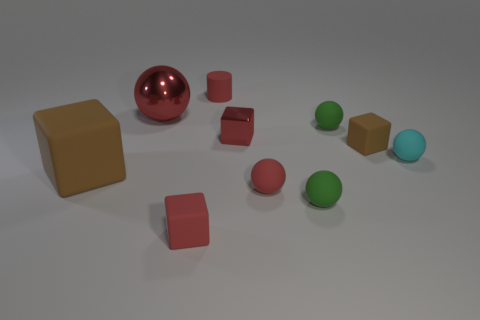There is a rubber cylinder that is the same size as the metallic cube; what is its color?
Give a very brief answer. Red. Is the number of small objects that are to the right of the cyan thing less than the number of cylinders left of the big block?
Your answer should be compact. No. What number of tiny spheres are to the left of the red metal thing to the right of the small red cube that is in front of the small brown block?
Provide a succinct answer. 0. There is another shiny object that is the same shape as the cyan thing; what size is it?
Offer a very short reply. Large. Is there anything else that is the same size as the red cylinder?
Your answer should be compact. Yes. Is the number of metallic balls to the right of the big red thing less than the number of tiny red metallic cubes?
Keep it short and to the point. Yes. Is the big red object the same shape as the small brown thing?
Ensure brevity in your answer.  No. What color is the other metallic object that is the same shape as the big brown thing?
Ensure brevity in your answer.  Red. What number of rubber objects are the same color as the metallic block?
Keep it short and to the point. 3. What number of things are either tiny rubber objects in front of the shiny block or small brown cubes?
Your answer should be very brief. 5. 